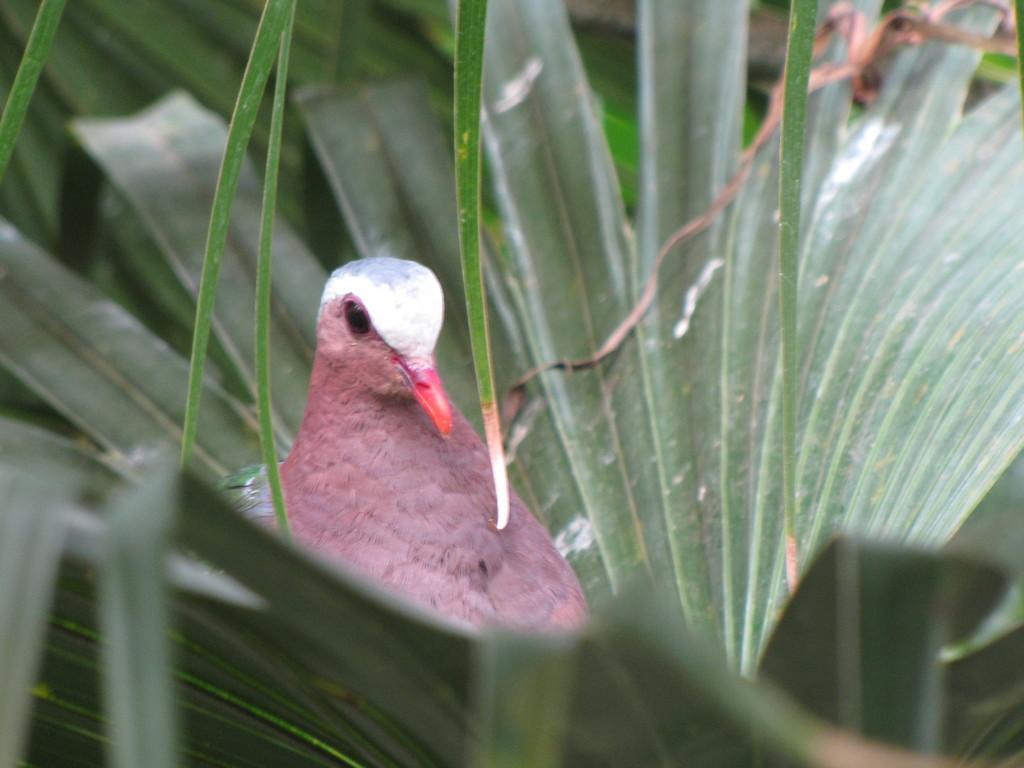Please provide a concise description of this image. In this picture I can see there is a pigeon and there are leaves around it and the backdrop is blurred. 